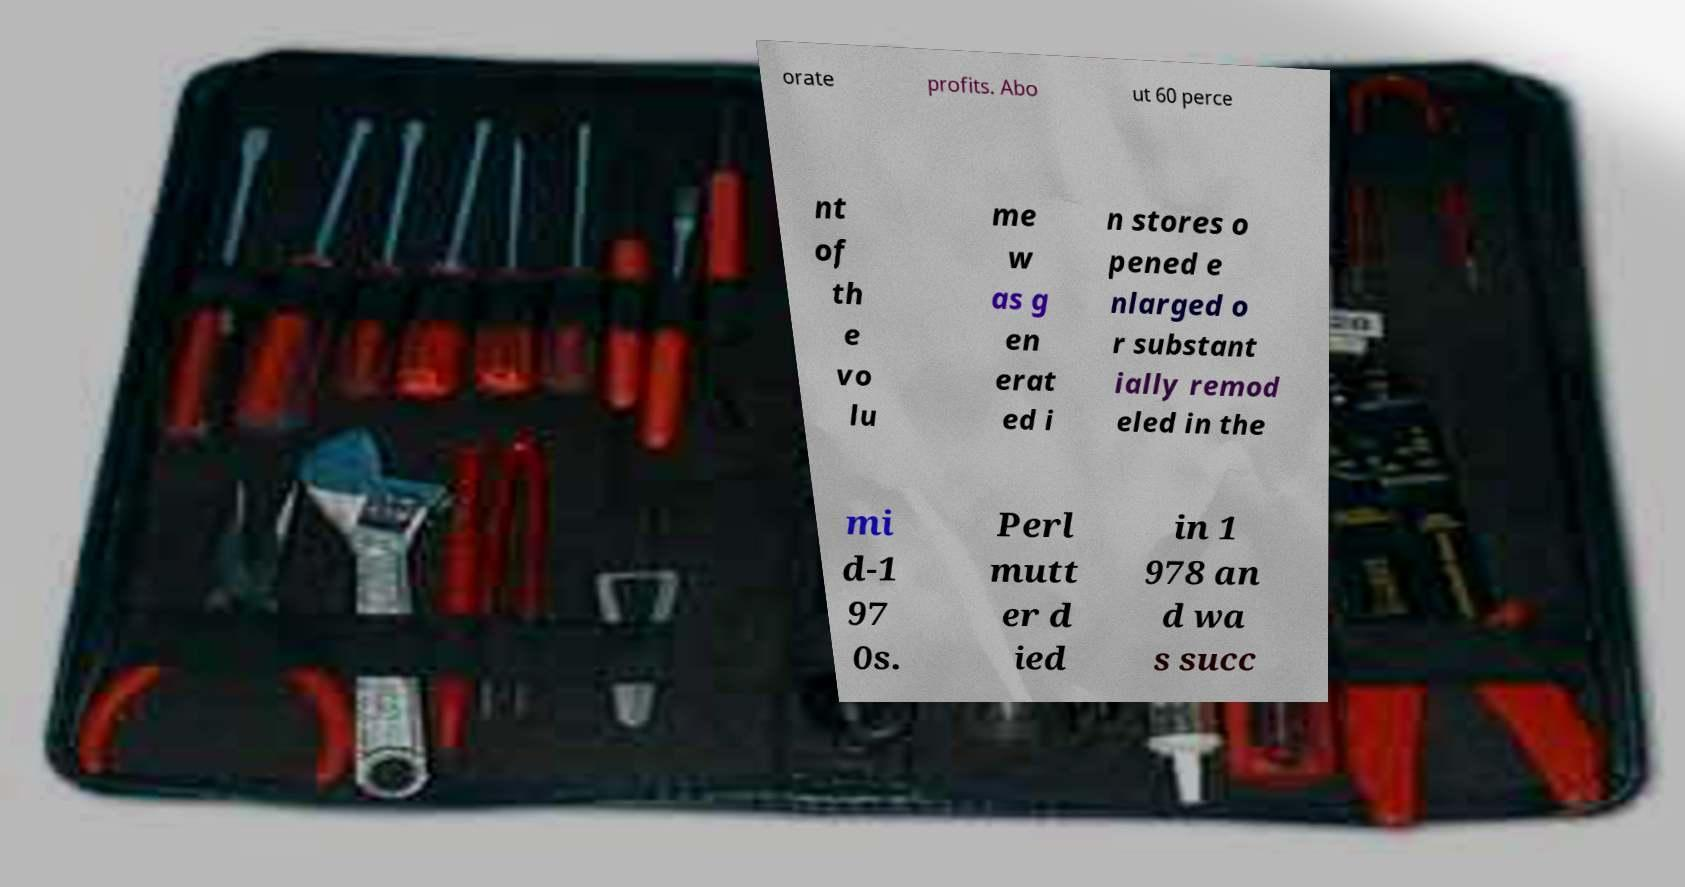I need the written content from this picture converted into text. Can you do that? orate profits. Abo ut 60 perce nt of th e vo lu me w as g en erat ed i n stores o pened e nlarged o r substant ially remod eled in the mi d-1 97 0s. Perl mutt er d ied in 1 978 an d wa s succ 